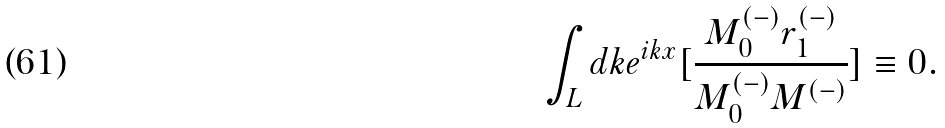Convert formula to latex. <formula><loc_0><loc_0><loc_500><loc_500>\int _ { L } d k e ^ { i k x } [ \frac { M ^ { ( - ) } _ { 0 } r ^ { ( - ) } _ { 1 } } { M ^ { ( - ) } _ { 0 } M ^ { ( - ) } } ] \equiv 0 .</formula> 